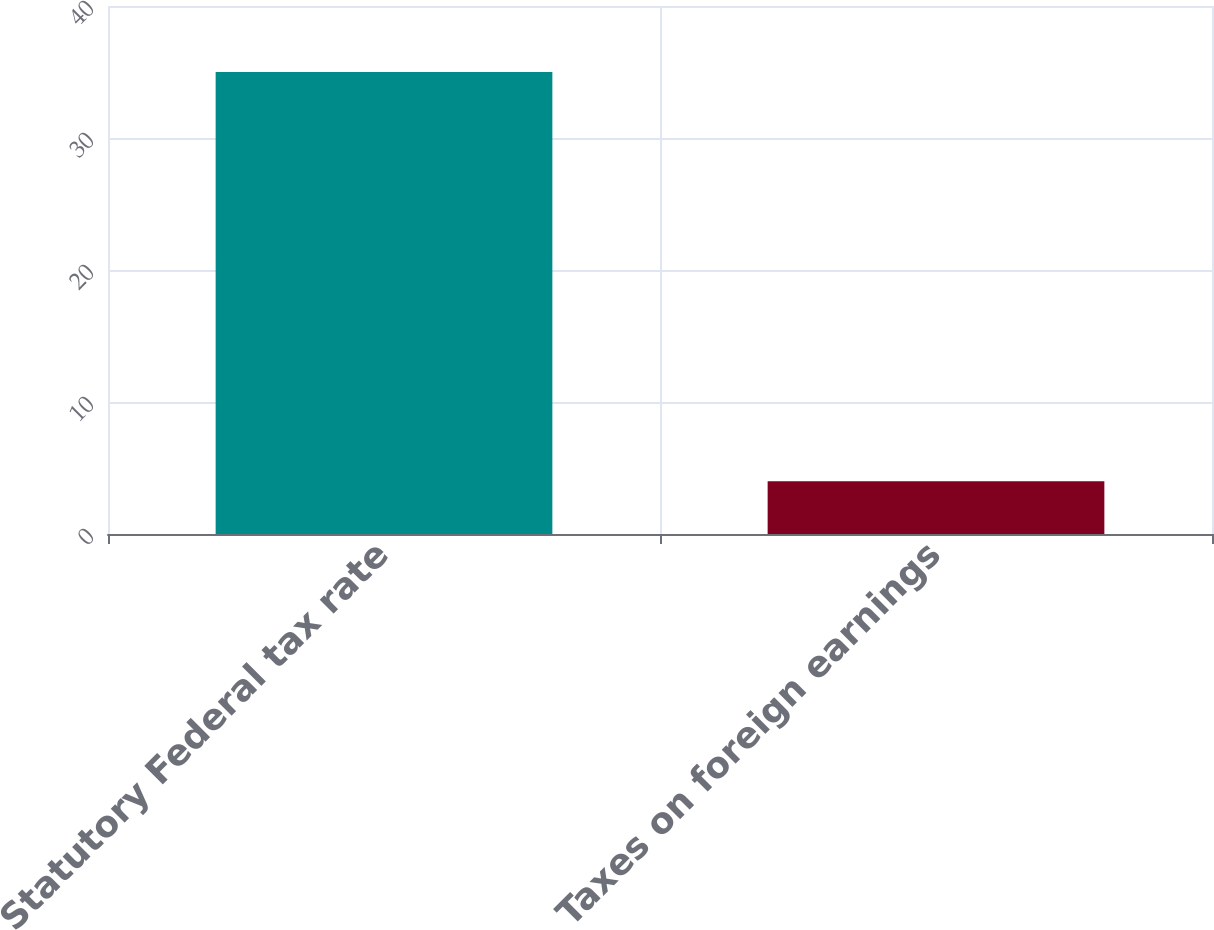Convert chart to OTSL. <chart><loc_0><loc_0><loc_500><loc_500><bar_chart><fcel>Statutory Federal tax rate<fcel>Taxes on foreign earnings<nl><fcel>35<fcel>4<nl></chart> 